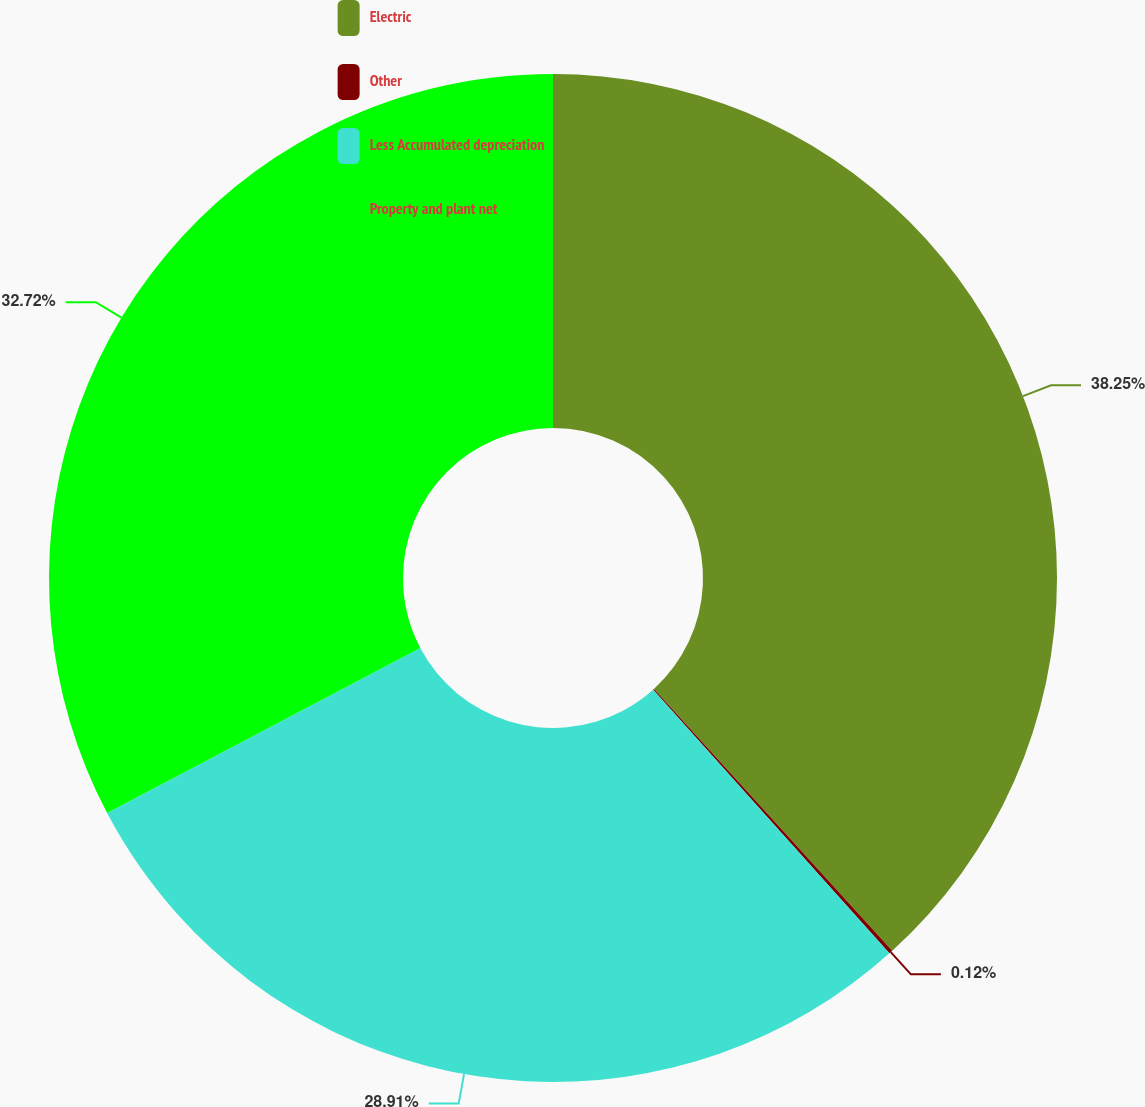<chart> <loc_0><loc_0><loc_500><loc_500><pie_chart><fcel>Electric<fcel>Other<fcel>Less Accumulated depreciation<fcel>Property and plant net<nl><fcel>38.25%<fcel>0.12%<fcel>28.91%<fcel>32.72%<nl></chart> 